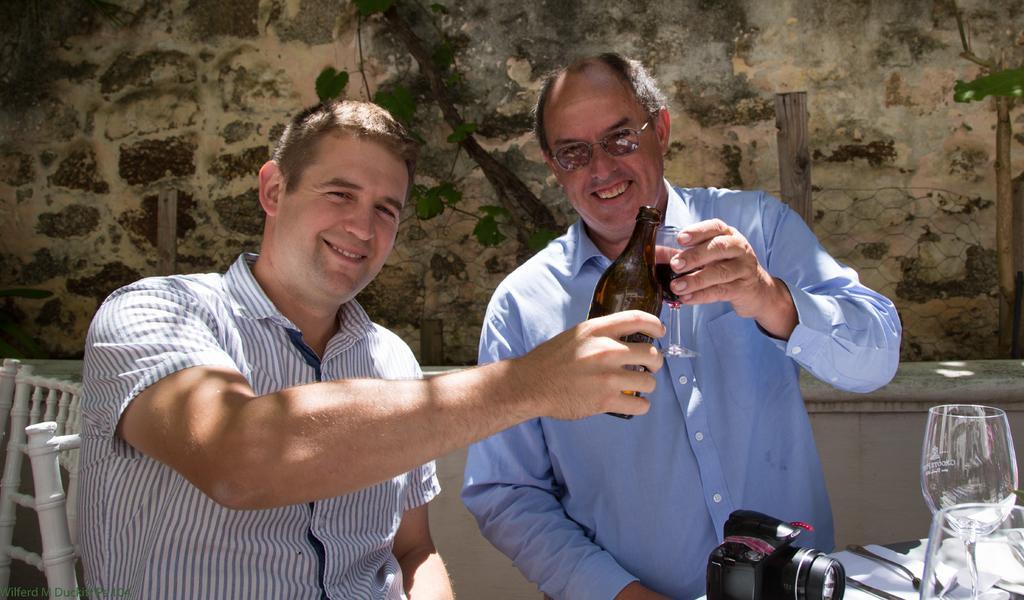Could you give a brief overview of what you see in this image? In this image, we can see two persons wearing clothes. The person who is on the left side of the image holding a bottle with his hand. There is an another person in the middle of the image holding a glass with his hand. There is a glass and camera on the table which is in the bottom right of the image. There is a chair in the bottom left of the image. In the background, we can see fencing and wall. 